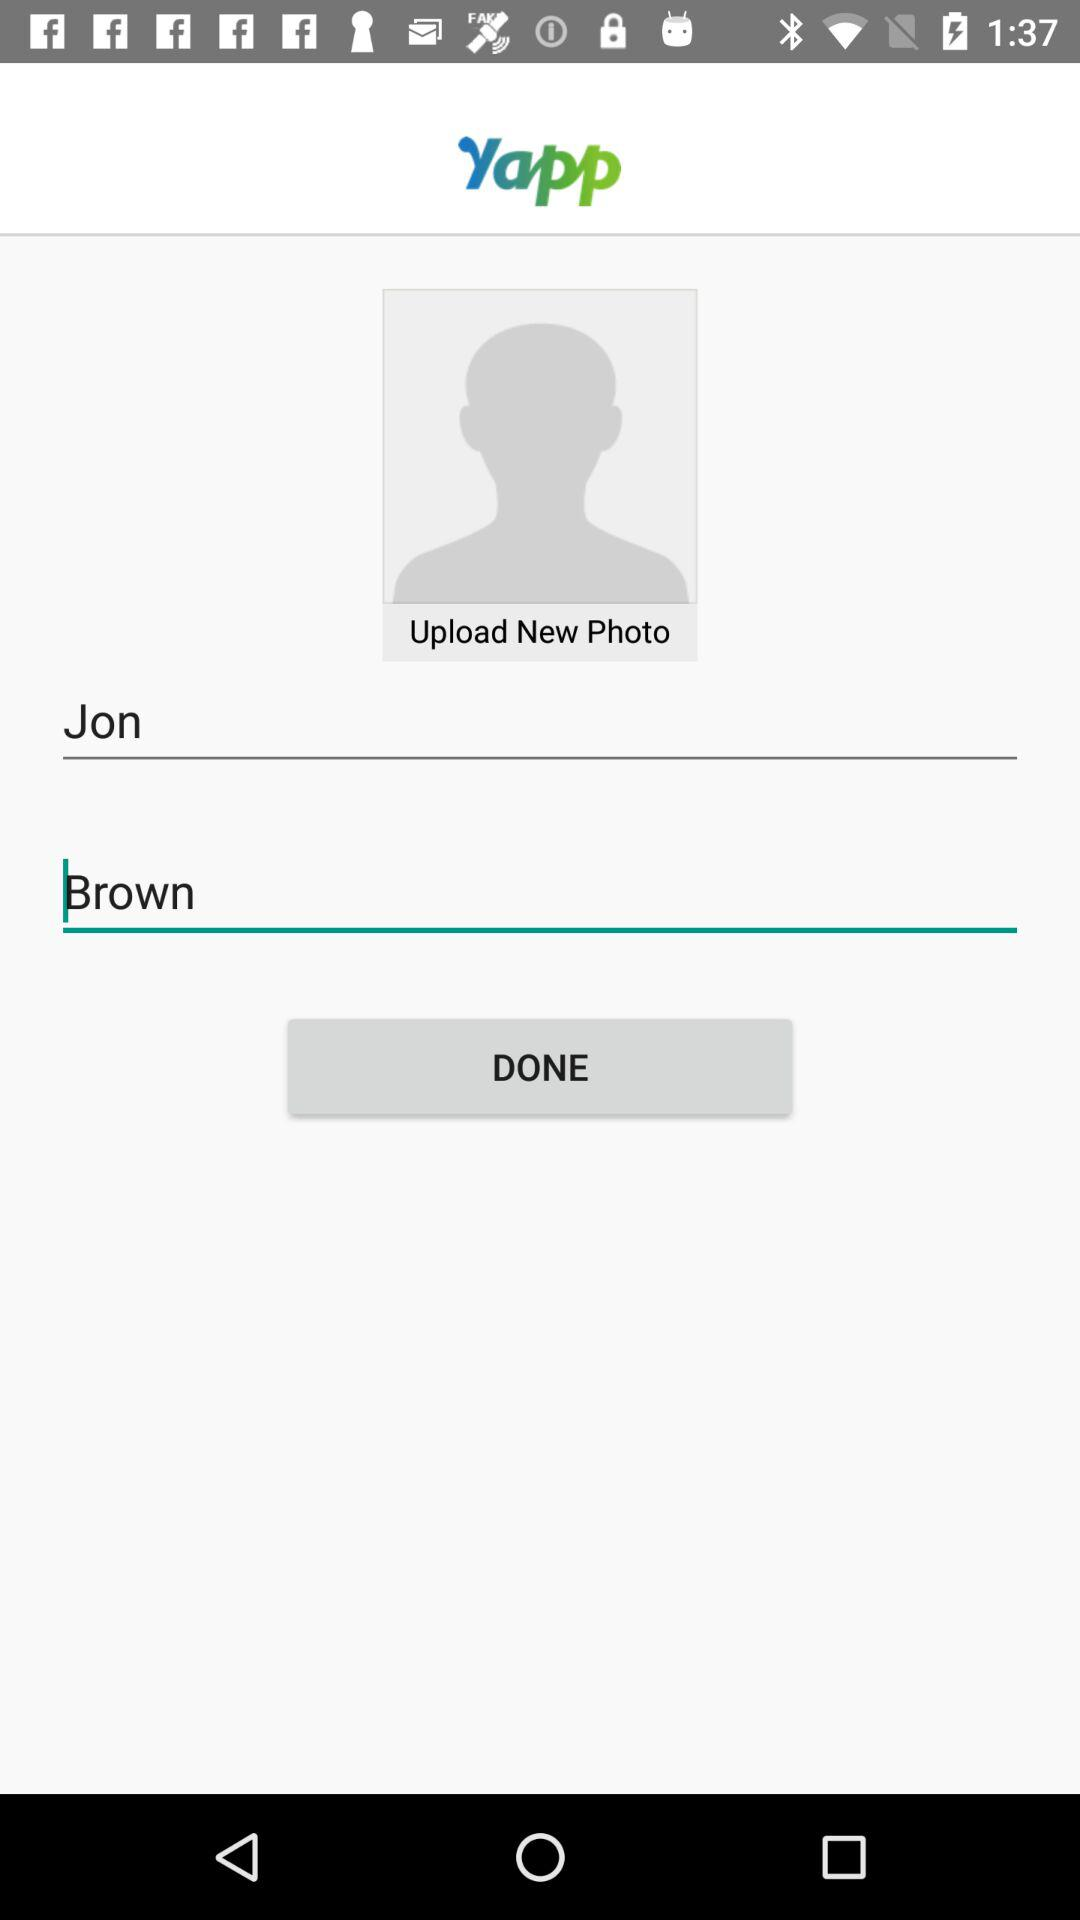What is the name of the application? The name of the application is "Yapp". 